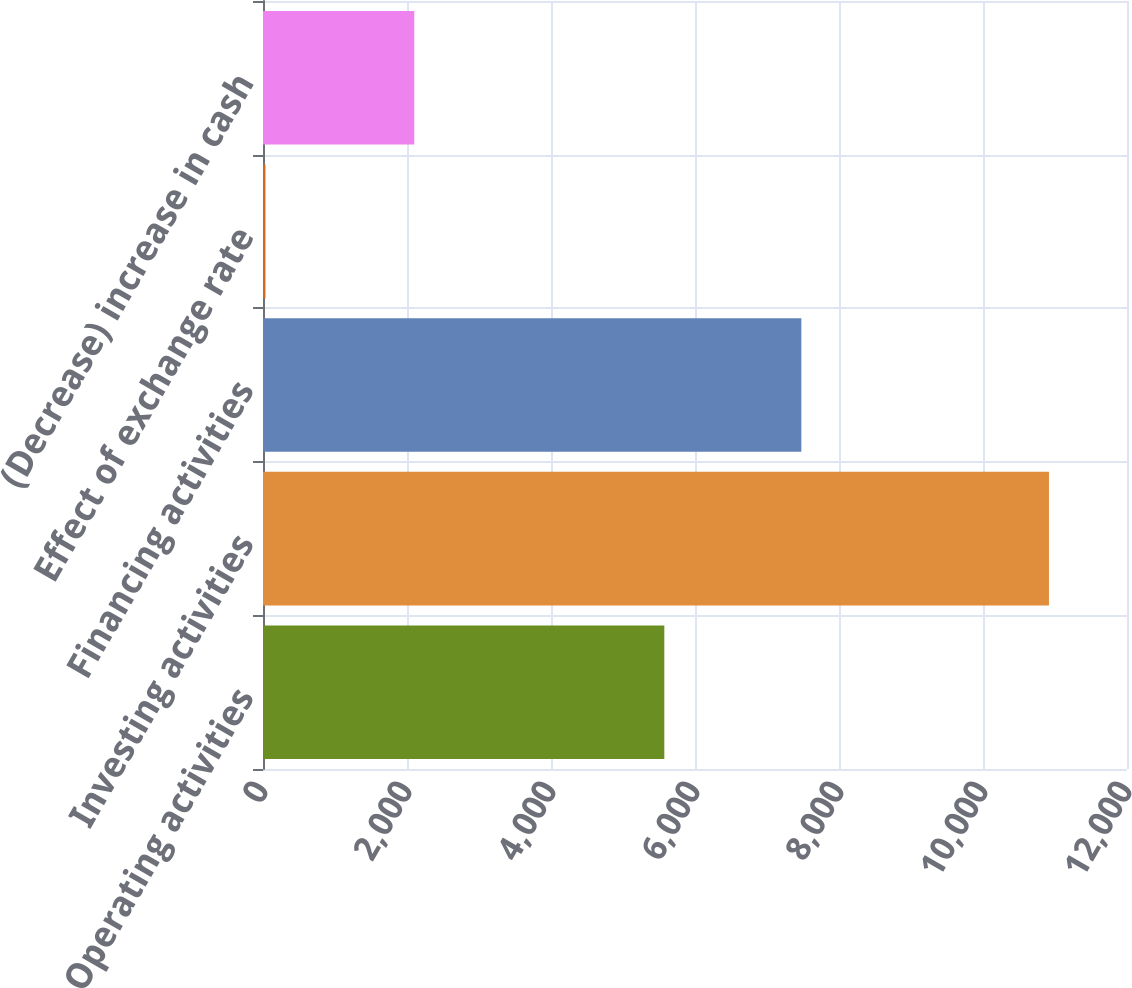Convert chart. <chart><loc_0><loc_0><loc_500><loc_500><bar_chart><fcel>Operating activities<fcel>Investing activities<fcel>Financing activities<fcel>Effect of exchange rate<fcel>(Decrease) increase in cash<nl><fcel>5574<fcel>10916<fcel>7477<fcel>34<fcel>2101<nl></chart> 